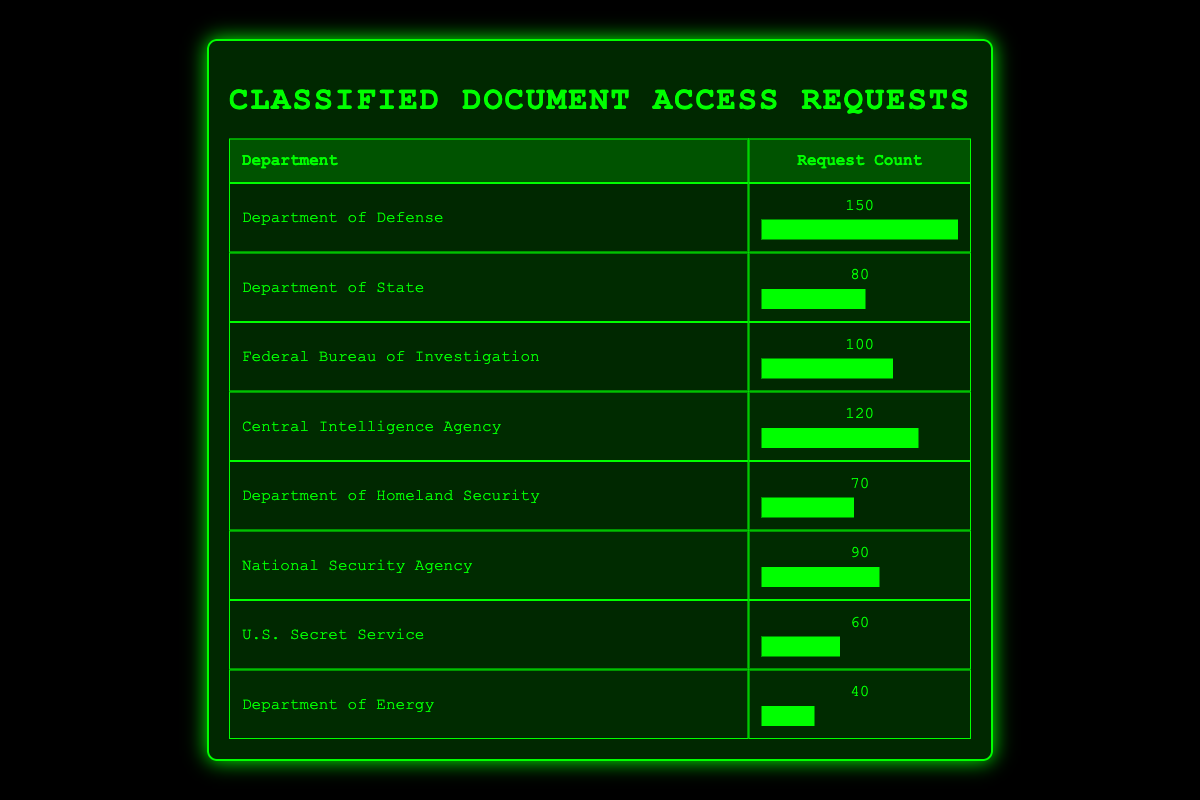What is the department with the highest number of access requests? The department with the highest request count is identified by looking for the maximum value in the request_count column. The Department of Defense has 150 requests, which is greater than any other department's request count.
Answer: Department of Defense How many access requests did the Department of State receive? The request count for the Department of State is located directly in the table under the corresponding row, which shows 80 requests.
Answer: 80 What is the total number of access requests across all departments? To find the total access requests, sum the request counts of all departments: 150 + 80 + 100 + 120 + 70 + 90 + 60 + 40 = 810.
Answer: 810 Which department has fewer access requests: the U.S. Secret Service or the Department of Energy? Comparing the requests for both departments: U.S. Secret Service has 60 requests, and Department of Energy has 40. Since 40 is less than 60, Department of Energy has fewer requests.
Answer: Department of Energy Is the request count for the Federal Bureau of Investigation greater than the Department of Homeland Security? The request count for FBI is 100 and for Homeland Security is 70. Since 100 is greater than 70, the statement is true.
Answer: Yes What is the average number of access requests per department? There are 8 departments, and the total number of requests is 810. To find the average, divide the total by the number of departments: 810 / 8 = 101.25.
Answer: 101.25 Which department had more access requests, the National Security Agency or the Central Intelligence Agency? The request count for National Security Agency is 90, and for Central Intelligence Agency is 120. Since 120 is greater than 90, the CIA had more requests.
Answer: Central Intelligence Agency What is the difference in access requests between the Department of Defense and the Department of Energy? To find the difference, subtract the request count for the Department of Energy (40) from the request count for the Department of Defense (150): 150 - 40 = 110.
Answer: 110 